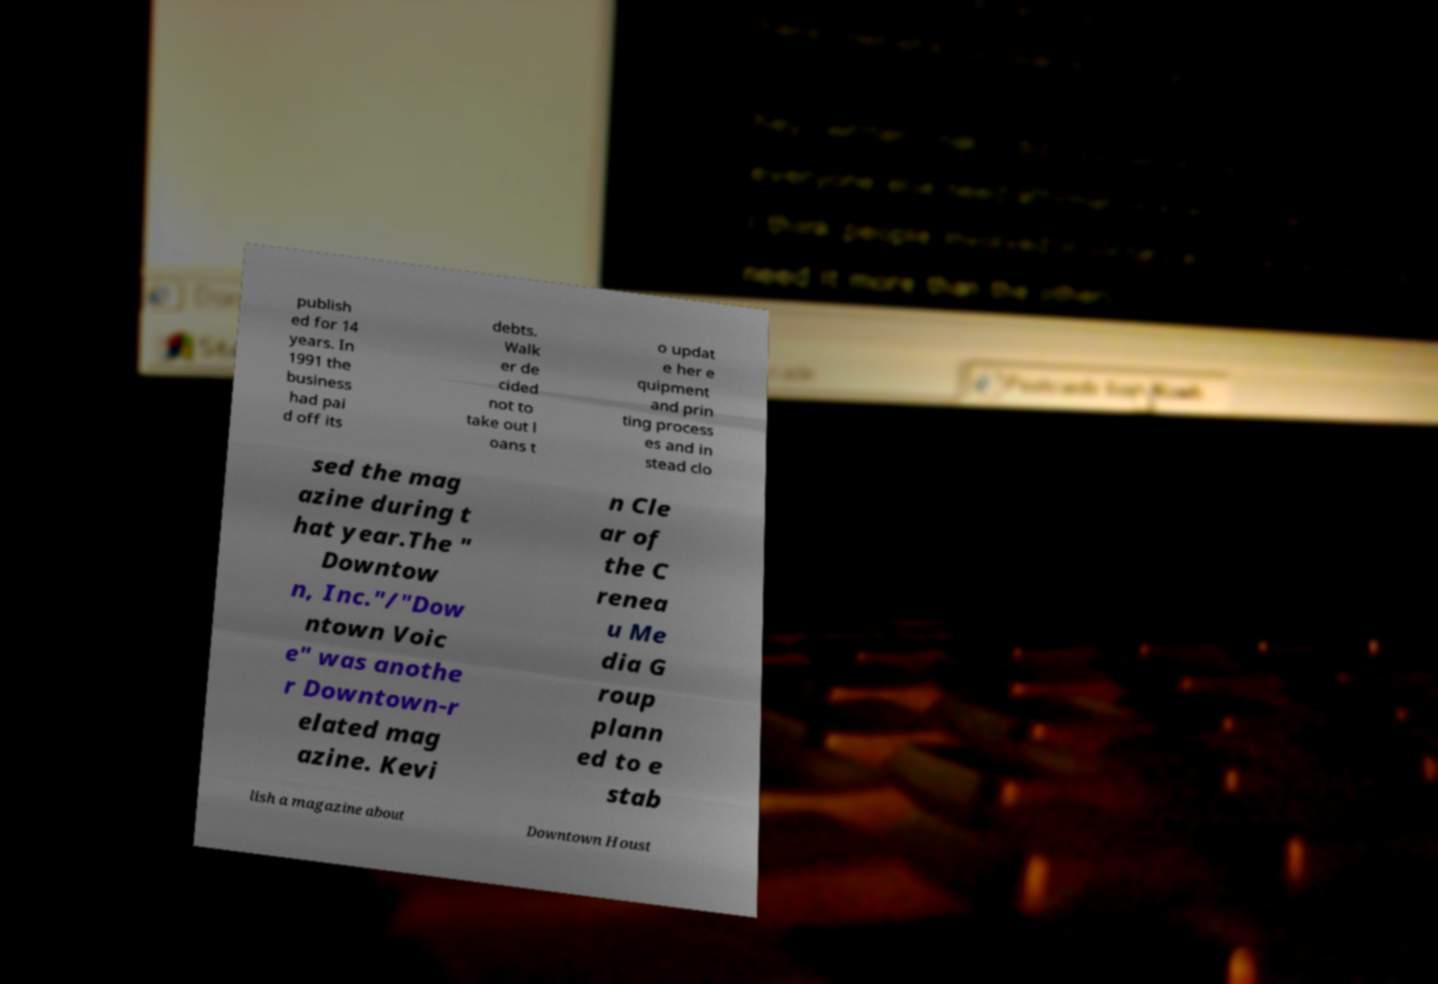Please read and relay the text visible in this image. What does it say? publish ed for 14 years. In 1991 the business had pai d off its debts. Walk er de cided not to take out l oans t o updat e her e quipment and prin ting process es and in stead clo sed the mag azine during t hat year.The " Downtow n, Inc."/"Dow ntown Voic e" was anothe r Downtown-r elated mag azine. Kevi n Cle ar of the C renea u Me dia G roup plann ed to e stab lish a magazine about Downtown Houst 